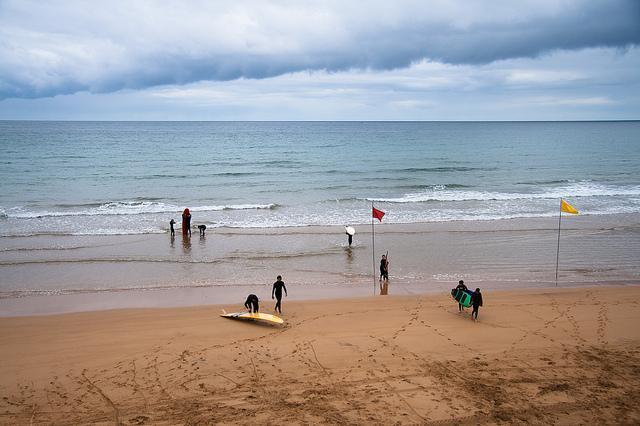How many giraffes are there?
Give a very brief answer. 0. 